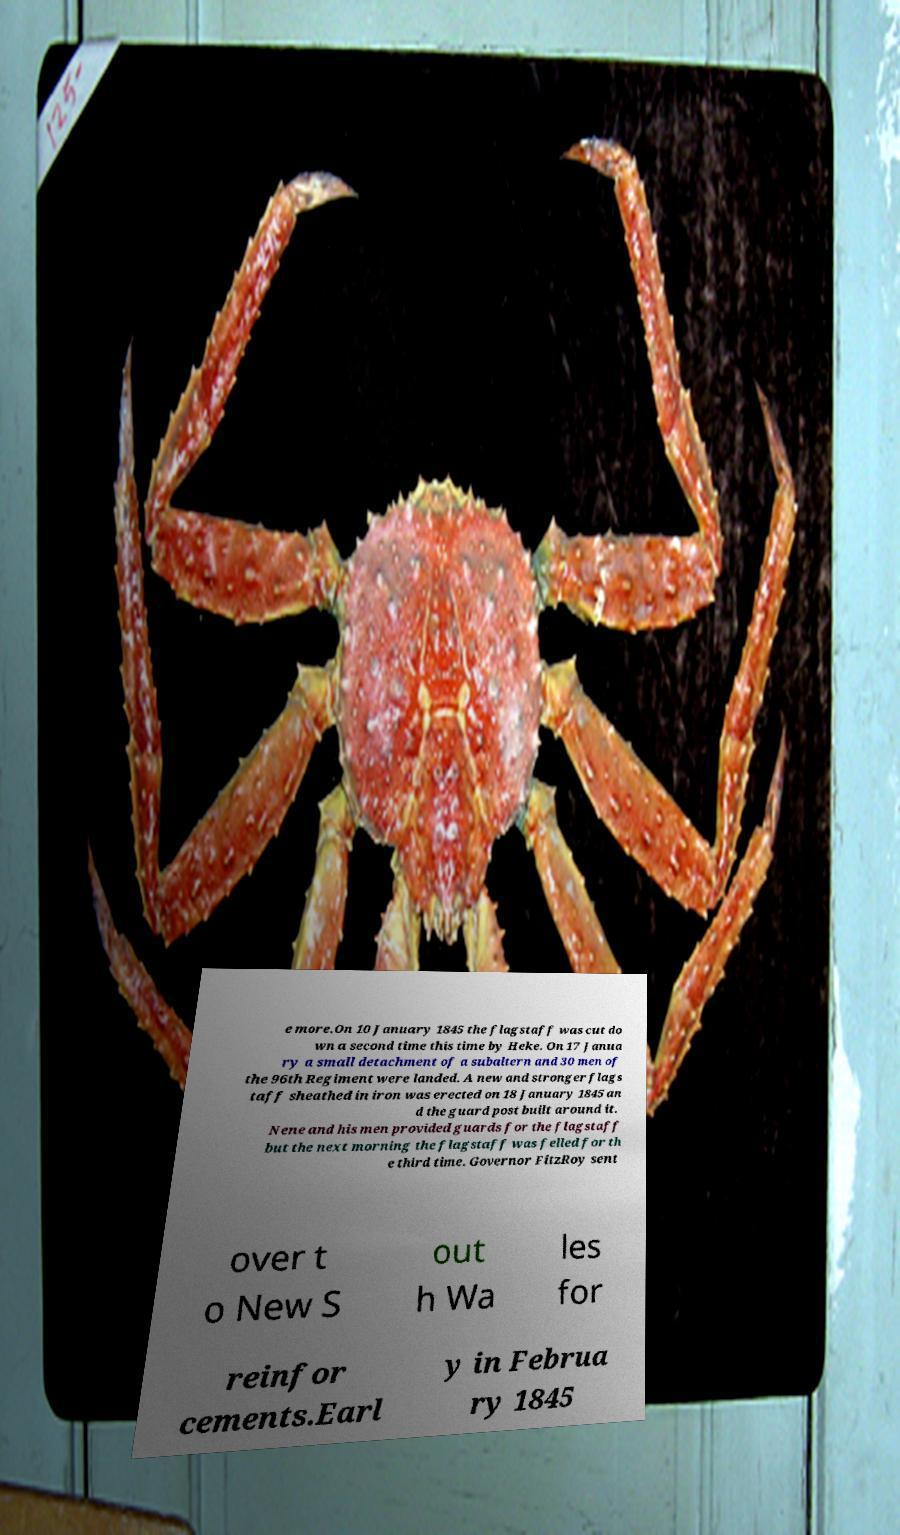What messages or text are displayed in this image? I need them in a readable, typed format. e more.On 10 January 1845 the flagstaff was cut do wn a second time this time by Heke. On 17 Janua ry a small detachment of a subaltern and 30 men of the 96th Regiment were landed. A new and stronger flags taff sheathed in iron was erected on 18 January 1845 an d the guard post built around it. Nene and his men provided guards for the flagstaff but the next morning the flagstaff was felled for th e third time. Governor FitzRoy sent over t o New S out h Wa les for reinfor cements.Earl y in Februa ry 1845 